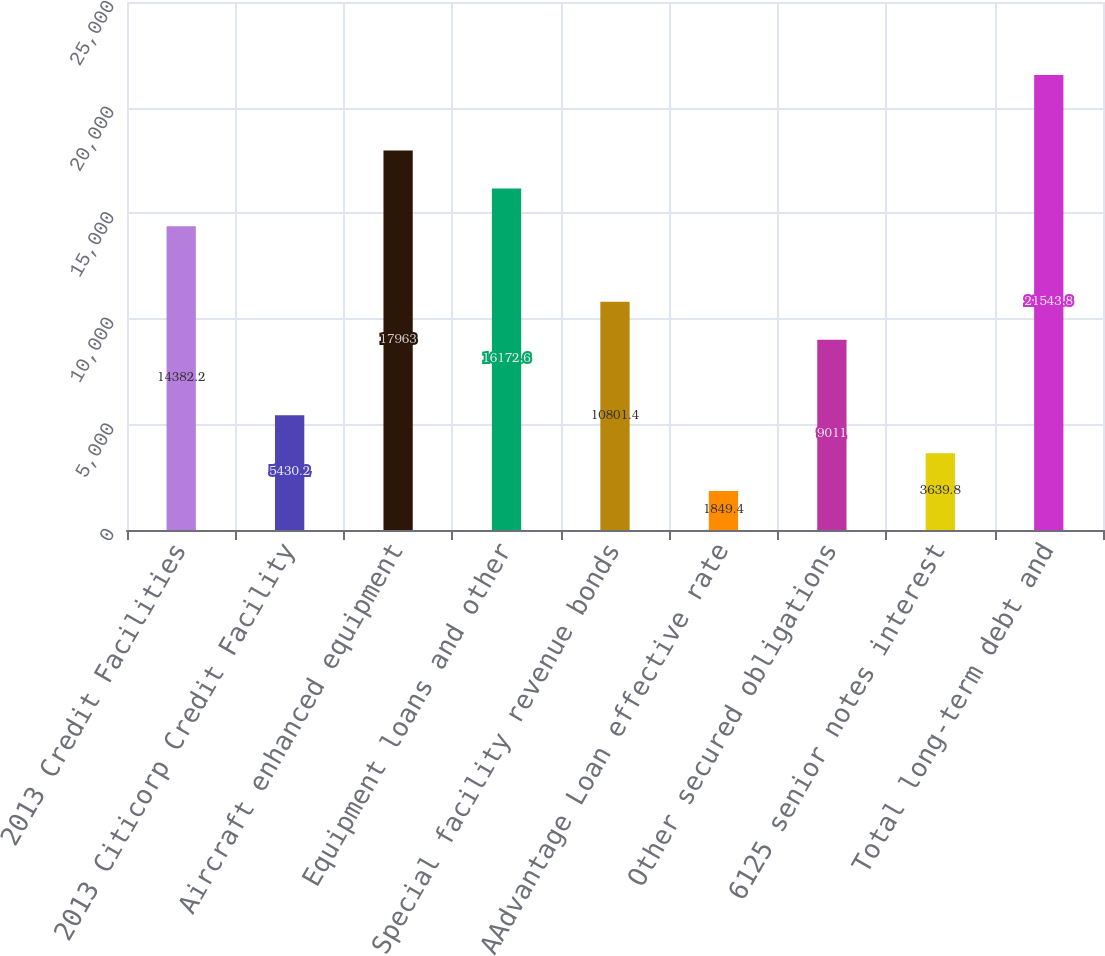Convert chart. <chart><loc_0><loc_0><loc_500><loc_500><bar_chart><fcel>2013 Credit Facilities<fcel>2013 Citicorp Credit Facility<fcel>Aircraft enhanced equipment<fcel>Equipment loans and other<fcel>Special facility revenue bonds<fcel>AAdvantage Loan effective rate<fcel>Other secured obligations<fcel>6125 senior notes interest<fcel>Total long-term debt and<nl><fcel>14382.2<fcel>5430.2<fcel>17963<fcel>16172.6<fcel>10801.4<fcel>1849.4<fcel>9011<fcel>3639.8<fcel>21543.8<nl></chart> 